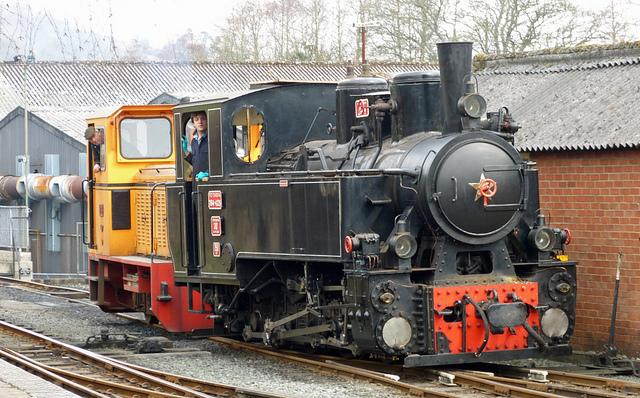Where were the first bricks used?

Choices:
A) middle east
B) spain
C) britain
D) america middle east 